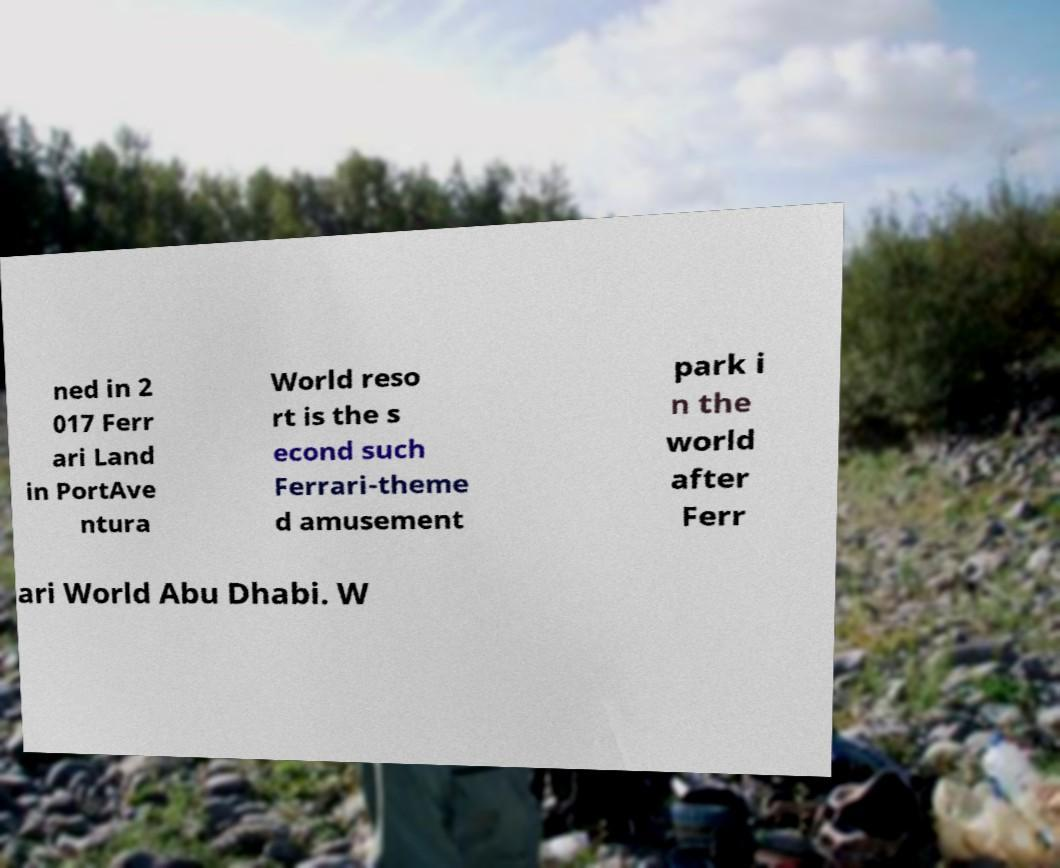Could you extract and type out the text from this image? ned in 2 017 Ferr ari Land in PortAve ntura World reso rt is the s econd such Ferrari-theme d amusement park i n the world after Ferr ari World Abu Dhabi. W 